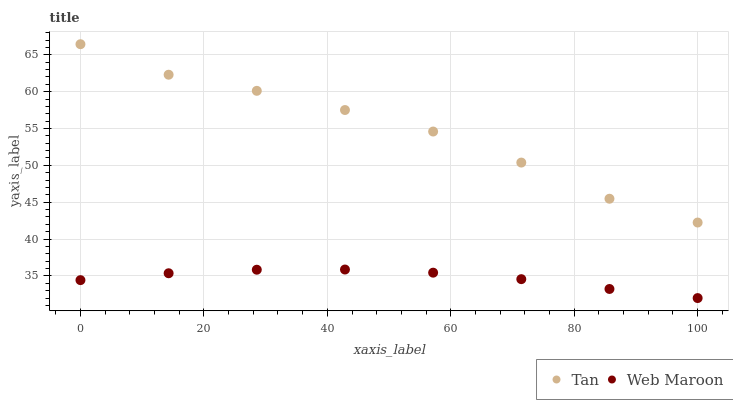Does Web Maroon have the minimum area under the curve?
Answer yes or no. Yes. Does Tan have the maximum area under the curve?
Answer yes or no. Yes. Does Web Maroon have the maximum area under the curve?
Answer yes or no. No. Is Web Maroon the smoothest?
Answer yes or no. Yes. Is Tan the roughest?
Answer yes or no. Yes. Is Web Maroon the roughest?
Answer yes or no. No. Does Web Maroon have the lowest value?
Answer yes or no. Yes. Does Tan have the highest value?
Answer yes or no. Yes. Does Web Maroon have the highest value?
Answer yes or no. No. Is Web Maroon less than Tan?
Answer yes or no. Yes. Is Tan greater than Web Maroon?
Answer yes or no. Yes. Does Web Maroon intersect Tan?
Answer yes or no. No. 